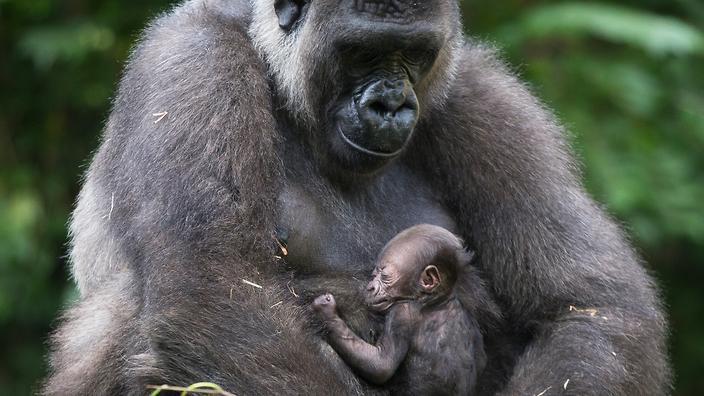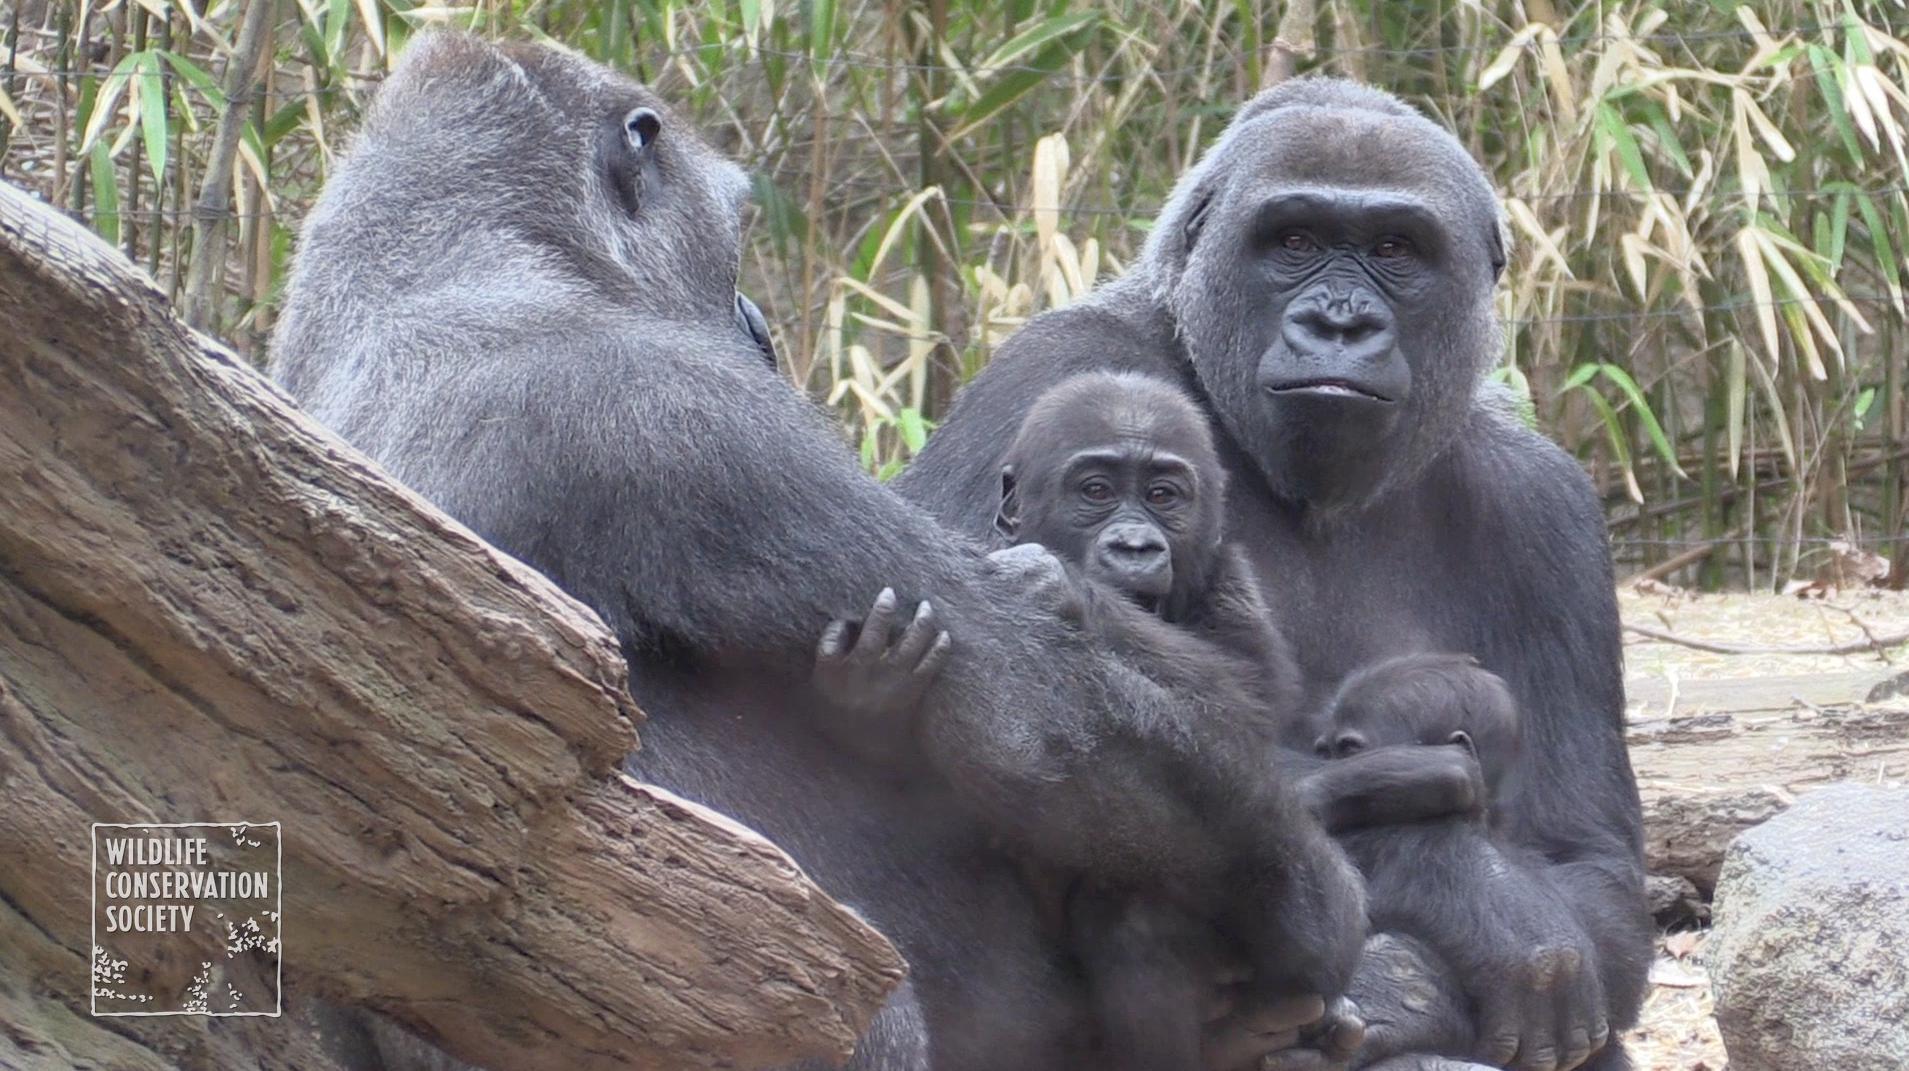The first image is the image on the left, the second image is the image on the right. For the images shown, is this caption "A baby primate lies on an adult in each of the images." true? Answer yes or no. No. The first image is the image on the left, the second image is the image on the right. Considering the images on both sides, is "A baby gorilla is clinging to the chest of an adult gorilla in one image, and the other image includes at least one baby gorilla in a different position [than the aforementioned image]." valid? Answer yes or no. Yes. 